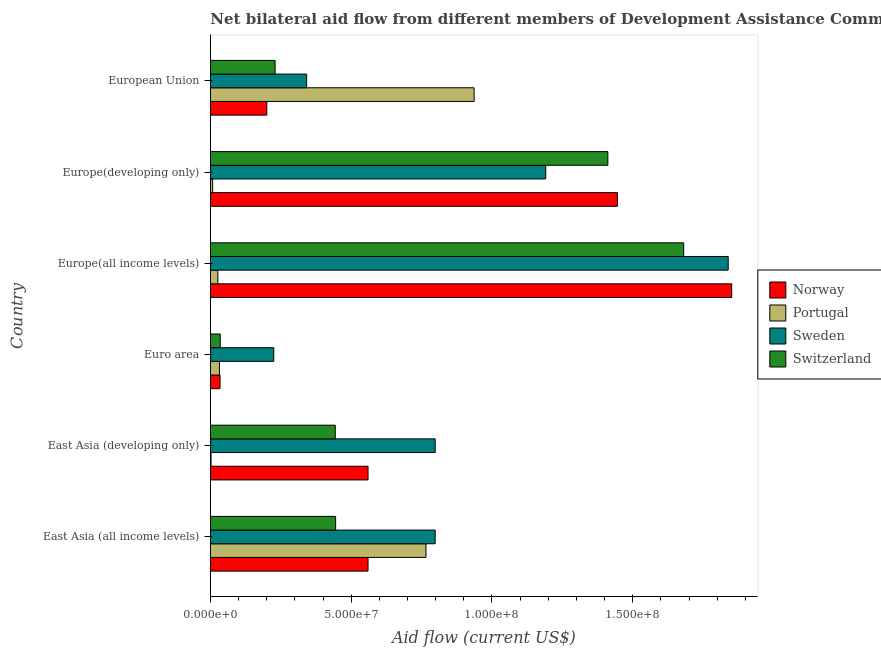Are the number of bars per tick equal to the number of legend labels?
Your answer should be compact. Yes. How many bars are there on the 6th tick from the top?
Your answer should be compact. 4. How many bars are there on the 2nd tick from the bottom?
Provide a short and direct response. 4. What is the label of the 3rd group of bars from the top?
Offer a very short reply. Europe(all income levels). In how many cases, is the number of bars for a given country not equal to the number of legend labels?
Make the answer very short. 0. What is the amount of aid given by norway in Euro area?
Provide a short and direct response. 3.40e+06. Across all countries, what is the maximum amount of aid given by portugal?
Offer a very short reply. 9.37e+07. Across all countries, what is the minimum amount of aid given by portugal?
Your response must be concise. 2.00e+05. In which country was the amount of aid given by sweden maximum?
Your answer should be very brief. Europe(all income levels). In which country was the amount of aid given by portugal minimum?
Provide a succinct answer. East Asia (developing only). What is the total amount of aid given by switzerland in the graph?
Your response must be concise. 4.24e+08. What is the difference between the amount of aid given by portugal in Europe(all income levels) and that in European Union?
Provide a short and direct response. -9.10e+07. What is the difference between the amount of aid given by sweden in East Asia (all income levels) and the amount of aid given by norway in East Asia (developing only)?
Give a very brief answer. 2.39e+07. What is the average amount of aid given by norway per country?
Provide a short and direct response. 7.75e+07. What is the difference between the amount of aid given by sweden and amount of aid given by norway in Europe(developing only)?
Offer a very short reply. -2.55e+07. What is the ratio of the amount of aid given by sweden in East Asia (developing only) to that in Europe(developing only)?
Keep it short and to the point. 0.67. Is the amount of aid given by switzerland in Europe(developing only) less than that in European Union?
Offer a terse response. No. Is the difference between the amount of aid given by portugal in East Asia (all income levels) and Euro area greater than the difference between the amount of aid given by norway in East Asia (all income levels) and Euro area?
Give a very brief answer. Yes. What is the difference between the highest and the second highest amount of aid given by switzerland?
Offer a very short reply. 2.69e+07. What is the difference between the highest and the lowest amount of aid given by norway?
Your answer should be compact. 1.82e+08. In how many countries, is the amount of aid given by portugal greater than the average amount of aid given by portugal taken over all countries?
Offer a terse response. 2. Is it the case that in every country, the sum of the amount of aid given by norway and amount of aid given by portugal is greater than the sum of amount of aid given by sweden and amount of aid given by switzerland?
Offer a terse response. No. What does the 4th bar from the bottom in European Union represents?
Your answer should be compact. Switzerland. Is it the case that in every country, the sum of the amount of aid given by norway and amount of aid given by portugal is greater than the amount of aid given by sweden?
Keep it short and to the point. No. Does the graph contain grids?
Offer a terse response. No. Where does the legend appear in the graph?
Make the answer very short. Center right. What is the title of the graph?
Give a very brief answer. Net bilateral aid flow from different members of Development Assistance Committee in the year 2002. Does "Structural Policies" appear as one of the legend labels in the graph?
Offer a terse response. No. What is the Aid flow (current US$) in Norway in East Asia (all income levels)?
Provide a short and direct response. 5.60e+07. What is the Aid flow (current US$) in Portugal in East Asia (all income levels)?
Provide a short and direct response. 7.66e+07. What is the Aid flow (current US$) of Sweden in East Asia (all income levels)?
Your answer should be compact. 7.98e+07. What is the Aid flow (current US$) in Switzerland in East Asia (all income levels)?
Keep it short and to the point. 4.45e+07. What is the Aid flow (current US$) in Norway in East Asia (developing only)?
Ensure brevity in your answer.  5.60e+07. What is the Aid flow (current US$) in Sweden in East Asia (developing only)?
Offer a terse response. 7.98e+07. What is the Aid flow (current US$) of Switzerland in East Asia (developing only)?
Make the answer very short. 4.43e+07. What is the Aid flow (current US$) of Norway in Euro area?
Give a very brief answer. 3.40e+06. What is the Aid flow (current US$) of Portugal in Euro area?
Your response must be concise. 3.18e+06. What is the Aid flow (current US$) in Sweden in Euro area?
Provide a short and direct response. 2.25e+07. What is the Aid flow (current US$) of Switzerland in Euro area?
Offer a terse response. 3.47e+06. What is the Aid flow (current US$) of Norway in Europe(all income levels)?
Offer a very short reply. 1.85e+08. What is the Aid flow (current US$) in Portugal in Europe(all income levels)?
Offer a terse response. 2.62e+06. What is the Aid flow (current US$) of Sweden in Europe(all income levels)?
Keep it short and to the point. 1.84e+08. What is the Aid flow (current US$) in Switzerland in Europe(all income levels)?
Offer a very short reply. 1.68e+08. What is the Aid flow (current US$) of Norway in Europe(developing only)?
Ensure brevity in your answer.  1.45e+08. What is the Aid flow (current US$) in Portugal in Europe(developing only)?
Keep it short and to the point. 7.70e+05. What is the Aid flow (current US$) of Sweden in Europe(developing only)?
Keep it short and to the point. 1.19e+08. What is the Aid flow (current US$) in Switzerland in Europe(developing only)?
Keep it short and to the point. 1.41e+08. What is the Aid flow (current US$) of Norway in European Union?
Give a very brief answer. 2.00e+07. What is the Aid flow (current US$) in Portugal in European Union?
Make the answer very short. 9.37e+07. What is the Aid flow (current US$) of Sweden in European Union?
Give a very brief answer. 3.42e+07. What is the Aid flow (current US$) of Switzerland in European Union?
Your response must be concise. 2.30e+07. Across all countries, what is the maximum Aid flow (current US$) of Norway?
Keep it short and to the point. 1.85e+08. Across all countries, what is the maximum Aid flow (current US$) of Portugal?
Keep it short and to the point. 9.37e+07. Across all countries, what is the maximum Aid flow (current US$) in Sweden?
Your answer should be compact. 1.84e+08. Across all countries, what is the maximum Aid flow (current US$) in Switzerland?
Give a very brief answer. 1.68e+08. Across all countries, what is the minimum Aid flow (current US$) of Norway?
Give a very brief answer. 3.40e+06. Across all countries, what is the minimum Aid flow (current US$) in Portugal?
Keep it short and to the point. 2.00e+05. Across all countries, what is the minimum Aid flow (current US$) of Sweden?
Keep it short and to the point. 2.25e+07. Across all countries, what is the minimum Aid flow (current US$) in Switzerland?
Provide a short and direct response. 3.47e+06. What is the total Aid flow (current US$) of Norway in the graph?
Ensure brevity in your answer.  4.65e+08. What is the total Aid flow (current US$) of Portugal in the graph?
Provide a short and direct response. 1.77e+08. What is the total Aid flow (current US$) of Sweden in the graph?
Provide a succinct answer. 5.19e+08. What is the total Aid flow (current US$) in Switzerland in the graph?
Provide a succinct answer. 4.24e+08. What is the difference between the Aid flow (current US$) of Norway in East Asia (all income levels) and that in East Asia (developing only)?
Offer a terse response. 0. What is the difference between the Aid flow (current US$) in Portugal in East Asia (all income levels) and that in East Asia (developing only)?
Give a very brief answer. 7.64e+07. What is the difference between the Aid flow (current US$) of Sweden in East Asia (all income levels) and that in East Asia (developing only)?
Provide a short and direct response. 0. What is the difference between the Aid flow (current US$) of Norway in East Asia (all income levels) and that in Euro area?
Your response must be concise. 5.26e+07. What is the difference between the Aid flow (current US$) of Portugal in East Asia (all income levels) and that in Euro area?
Offer a terse response. 7.34e+07. What is the difference between the Aid flow (current US$) of Sweden in East Asia (all income levels) and that in Euro area?
Your answer should be very brief. 5.73e+07. What is the difference between the Aid flow (current US$) in Switzerland in East Asia (all income levels) and that in Euro area?
Offer a terse response. 4.10e+07. What is the difference between the Aid flow (current US$) of Norway in East Asia (all income levels) and that in Europe(all income levels)?
Provide a succinct answer. -1.29e+08. What is the difference between the Aid flow (current US$) in Portugal in East Asia (all income levels) and that in Europe(all income levels)?
Provide a succinct answer. 7.39e+07. What is the difference between the Aid flow (current US$) in Sweden in East Asia (all income levels) and that in Europe(all income levels)?
Your answer should be very brief. -1.04e+08. What is the difference between the Aid flow (current US$) of Switzerland in East Asia (all income levels) and that in Europe(all income levels)?
Make the answer very short. -1.24e+08. What is the difference between the Aid flow (current US$) of Norway in East Asia (all income levels) and that in Europe(developing only)?
Offer a terse response. -8.86e+07. What is the difference between the Aid flow (current US$) in Portugal in East Asia (all income levels) and that in Europe(developing only)?
Your answer should be compact. 7.58e+07. What is the difference between the Aid flow (current US$) of Sweden in East Asia (all income levels) and that in Europe(developing only)?
Offer a terse response. -3.93e+07. What is the difference between the Aid flow (current US$) of Switzerland in East Asia (all income levels) and that in Europe(developing only)?
Your response must be concise. -9.67e+07. What is the difference between the Aid flow (current US$) of Norway in East Asia (all income levels) and that in European Union?
Keep it short and to the point. 3.60e+07. What is the difference between the Aid flow (current US$) in Portugal in East Asia (all income levels) and that in European Union?
Your response must be concise. -1.71e+07. What is the difference between the Aid flow (current US$) in Sweden in East Asia (all income levels) and that in European Union?
Keep it short and to the point. 4.57e+07. What is the difference between the Aid flow (current US$) of Switzerland in East Asia (all income levels) and that in European Union?
Make the answer very short. 2.15e+07. What is the difference between the Aid flow (current US$) in Norway in East Asia (developing only) and that in Euro area?
Give a very brief answer. 5.26e+07. What is the difference between the Aid flow (current US$) of Portugal in East Asia (developing only) and that in Euro area?
Give a very brief answer. -2.98e+06. What is the difference between the Aid flow (current US$) of Sweden in East Asia (developing only) and that in Euro area?
Your answer should be compact. 5.73e+07. What is the difference between the Aid flow (current US$) of Switzerland in East Asia (developing only) and that in Euro area?
Your response must be concise. 4.09e+07. What is the difference between the Aid flow (current US$) of Norway in East Asia (developing only) and that in Europe(all income levels)?
Provide a succinct answer. -1.29e+08. What is the difference between the Aid flow (current US$) in Portugal in East Asia (developing only) and that in Europe(all income levels)?
Give a very brief answer. -2.42e+06. What is the difference between the Aid flow (current US$) in Sweden in East Asia (developing only) and that in Europe(all income levels)?
Offer a terse response. -1.04e+08. What is the difference between the Aid flow (current US$) in Switzerland in East Asia (developing only) and that in Europe(all income levels)?
Provide a succinct answer. -1.24e+08. What is the difference between the Aid flow (current US$) in Norway in East Asia (developing only) and that in Europe(developing only)?
Keep it short and to the point. -8.86e+07. What is the difference between the Aid flow (current US$) of Portugal in East Asia (developing only) and that in Europe(developing only)?
Your response must be concise. -5.70e+05. What is the difference between the Aid flow (current US$) in Sweden in East Asia (developing only) and that in Europe(developing only)?
Offer a terse response. -3.93e+07. What is the difference between the Aid flow (current US$) of Switzerland in East Asia (developing only) and that in Europe(developing only)?
Offer a terse response. -9.68e+07. What is the difference between the Aid flow (current US$) of Norway in East Asia (developing only) and that in European Union?
Offer a very short reply. 3.60e+07. What is the difference between the Aid flow (current US$) in Portugal in East Asia (developing only) and that in European Union?
Provide a short and direct response. -9.35e+07. What is the difference between the Aid flow (current US$) in Sweden in East Asia (developing only) and that in European Union?
Provide a short and direct response. 4.57e+07. What is the difference between the Aid flow (current US$) of Switzerland in East Asia (developing only) and that in European Union?
Your response must be concise. 2.14e+07. What is the difference between the Aid flow (current US$) in Norway in Euro area and that in Europe(all income levels)?
Offer a terse response. -1.82e+08. What is the difference between the Aid flow (current US$) in Portugal in Euro area and that in Europe(all income levels)?
Ensure brevity in your answer.  5.60e+05. What is the difference between the Aid flow (current US$) in Sweden in Euro area and that in Europe(all income levels)?
Your answer should be very brief. -1.61e+08. What is the difference between the Aid flow (current US$) in Switzerland in Euro area and that in Europe(all income levels)?
Provide a short and direct response. -1.65e+08. What is the difference between the Aid flow (current US$) in Norway in Euro area and that in Europe(developing only)?
Your response must be concise. -1.41e+08. What is the difference between the Aid flow (current US$) in Portugal in Euro area and that in Europe(developing only)?
Give a very brief answer. 2.41e+06. What is the difference between the Aid flow (current US$) in Sweden in Euro area and that in Europe(developing only)?
Keep it short and to the point. -9.66e+07. What is the difference between the Aid flow (current US$) of Switzerland in Euro area and that in Europe(developing only)?
Your answer should be compact. -1.38e+08. What is the difference between the Aid flow (current US$) of Norway in Euro area and that in European Union?
Your response must be concise. -1.66e+07. What is the difference between the Aid flow (current US$) in Portugal in Euro area and that in European Union?
Provide a short and direct response. -9.05e+07. What is the difference between the Aid flow (current US$) in Sweden in Euro area and that in European Union?
Make the answer very short. -1.17e+07. What is the difference between the Aid flow (current US$) of Switzerland in Euro area and that in European Union?
Ensure brevity in your answer.  -1.95e+07. What is the difference between the Aid flow (current US$) in Norway in Europe(all income levels) and that in Europe(developing only)?
Ensure brevity in your answer.  4.06e+07. What is the difference between the Aid flow (current US$) in Portugal in Europe(all income levels) and that in Europe(developing only)?
Your answer should be very brief. 1.85e+06. What is the difference between the Aid flow (current US$) of Sweden in Europe(all income levels) and that in Europe(developing only)?
Provide a short and direct response. 6.48e+07. What is the difference between the Aid flow (current US$) in Switzerland in Europe(all income levels) and that in Europe(developing only)?
Provide a short and direct response. 2.69e+07. What is the difference between the Aid flow (current US$) in Norway in Europe(all income levels) and that in European Union?
Provide a short and direct response. 1.65e+08. What is the difference between the Aid flow (current US$) in Portugal in Europe(all income levels) and that in European Union?
Keep it short and to the point. -9.10e+07. What is the difference between the Aid flow (current US$) of Sweden in Europe(all income levels) and that in European Union?
Provide a succinct answer. 1.50e+08. What is the difference between the Aid flow (current US$) of Switzerland in Europe(all income levels) and that in European Union?
Your answer should be compact. 1.45e+08. What is the difference between the Aid flow (current US$) of Norway in Europe(developing only) and that in European Union?
Your answer should be compact. 1.25e+08. What is the difference between the Aid flow (current US$) of Portugal in Europe(developing only) and that in European Union?
Your answer should be compact. -9.29e+07. What is the difference between the Aid flow (current US$) in Sweden in Europe(developing only) and that in European Union?
Provide a succinct answer. 8.49e+07. What is the difference between the Aid flow (current US$) in Switzerland in Europe(developing only) and that in European Union?
Give a very brief answer. 1.18e+08. What is the difference between the Aid flow (current US$) of Norway in East Asia (all income levels) and the Aid flow (current US$) of Portugal in East Asia (developing only)?
Your answer should be compact. 5.58e+07. What is the difference between the Aid flow (current US$) in Norway in East Asia (all income levels) and the Aid flow (current US$) in Sweden in East Asia (developing only)?
Your answer should be compact. -2.39e+07. What is the difference between the Aid flow (current US$) of Norway in East Asia (all income levels) and the Aid flow (current US$) of Switzerland in East Asia (developing only)?
Give a very brief answer. 1.16e+07. What is the difference between the Aid flow (current US$) of Portugal in East Asia (all income levels) and the Aid flow (current US$) of Sweden in East Asia (developing only)?
Your answer should be very brief. -3.27e+06. What is the difference between the Aid flow (current US$) of Portugal in East Asia (all income levels) and the Aid flow (current US$) of Switzerland in East Asia (developing only)?
Offer a terse response. 3.22e+07. What is the difference between the Aid flow (current US$) in Sweden in East Asia (all income levels) and the Aid flow (current US$) in Switzerland in East Asia (developing only)?
Keep it short and to the point. 3.55e+07. What is the difference between the Aid flow (current US$) in Norway in East Asia (all income levels) and the Aid flow (current US$) in Portugal in Euro area?
Give a very brief answer. 5.28e+07. What is the difference between the Aid flow (current US$) of Norway in East Asia (all income levels) and the Aid flow (current US$) of Sweden in Euro area?
Your answer should be very brief. 3.35e+07. What is the difference between the Aid flow (current US$) of Norway in East Asia (all income levels) and the Aid flow (current US$) of Switzerland in Euro area?
Offer a very short reply. 5.25e+07. What is the difference between the Aid flow (current US$) in Portugal in East Asia (all income levels) and the Aid flow (current US$) in Sweden in Euro area?
Your response must be concise. 5.41e+07. What is the difference between the Aid flow (current US$) in Portugal in East Asia (all income levels) and the Aid flow (current US$) in Switzerland in Euro area?
Your answer should be very brief. 7.31e+07. What is the difference between the Aid flow (current US$) of Sweden in East Asia (all income levels) and the Aid flow (current US$) of Switzerland in Euro area?
Make the answer very short. 7.64e+07. What is the difference between the Aid flow (current US$) of Norway in East Asia (all income levels) and the Aid flow (current US$) of Portugal in Europe(all income levels)?
Keep it short and to the point. 5.34e+07. What is the difference between the Aid flow (current US$) in Norway in East Asia (all income levels) and the Aid flow (current US$) in Sweden in Europe(all income levels)?
Your response must be concise. -1.28e+08. What is the difference between the Aid flow (current US$) in Norway in East Asia (all income levels) and the Aid flow (current US$) in Switzerland in Europe(all income levels)?
Your response must be concise. -1.12e+08. What is the difference between the Aid flow (current US$) in Portugal in East Asia (all income levels) and the Aid flow (current US$) in Sweden in Europe(all income levels)?
Ensure brevity in your answer.  -1.07e+08. What is the difference between the Aid flow (current US$) in Portugal in East Asia (all income levels) and the Aid flow (current US$) in Switzerland in Europe(all income levels)?
Make the answer very short. -9.16e+07. What is the difference between the Aid flow (current US$) in Sweden in East Asia (all income levels) and the Aid flow (current US$) in Switzerland in Europe(all income levels)?
Provide a succinct answer. -8.83e+07. What is the difference between the Aid flow (current US$) in Norway in East Asia (all income levels) and the Aid flow (current US$) in Portugal in Europe(developing only)?
Provide a short and direct response. 5.52e+07. What is the difference between the Aid flow (current US$) in Norway in East Asia (all income levels) and the Aid flow (current US$) in Sweden in Europe(developing only)?
Offer a very short reply. -6.31e+07. What is the difference between the Aid flow (current US$) in Norway in East Asia (all income levels) and the Aid flow (current US$) in Switzerland in Europe(developing only)?
Give a very brief answer. -8.52e+07. What is the difference between the Aid flow (current US$) in Portugal in East Asia (all income levels) and the Aid flow (current US$) in Sweden in Europe(developing only)?
Provide a short and direct response. -4.25e+07. What is the difference between the Aid flow (current US$) in Portugal in East Asia (all income levels) and the Aid flow (current US$) in Switzerland in Europe(developing only)?
Ensure brevity in your answer.  -6.46e+07. What is the difference between the Aid flow (current US$) in Sweden in East Asia (all income levels) and the Aid flow (current US$) in Switzerland in Europe(developing only)?
Offer a terse response. -6.13e+07. What is the difference between the Aid flow (current US$) in Norway in East Asia (all income levels) and the Aid flow (current US$) in Portugal in European Union?
Your response must be concise. -3.77e+07. What is the difference between the Aid flow (current US$) in Norway in East Asia (all income levels) and the Aid flow (current US$) in Sweden in European Union?
Provide a succinct answer. 2.18e+07. What is the difference between the Aid flow (current US$) of Norway in East Asia (all income levels) and the Aid flow (current US$) of Switzerland in European Union?
Make the answer very short. 3.30e+07. What is the difference between the Aid flow (current US$) in Portugal in East Asia (all income levels) and the Aid flow (current US$) in Sweden in European Union?
Provide a short and direct response. 4.24e+07. What is the difference between the Aid flow (current US$) of Portugal in East Asia (all income levels) and the Aid flow (current US$) of Switzerland in European Union?
Ensure brevity in your answer.  5.36e+07. What is the difference between the Aid flow (current US$) in Sweden in East Asia (all income levels) and the Aid flow (current US$) in Switzerland in European Union?
Provide a succinct answer. 5.69e+07. What is the difference between the Aid flow (current US$) in Norway in East Asia (developing only) and the Aid flow (current US$) in Portugal in Euro area?
Provide a short and direct response. 5.28e+07. What is the difference between the Aid flow (current US$) in Norway in East Asia (developing only) and the Aid flow (current US$) in Sweden in Euro area?
Provide a succinct answer. 3.35e+07. What is the difference between the Aid flow (current US$) of Norway in East Asia (developing only) and the Aid flow (current US$) of Switzerland in Euro area?
Your response must be concise. 5.25e+07. What is the difference between the Aid flow (current US$) of Portugal in East Asia (developing only) and the Aid flow (current US$) of Sweden in Euro area?
Provide a short and direct response. -2.23e+07. What is the difference between the Aid flow (current US$) of Portugal in East Asia (developing only) and the Aid flow (current US$) of Switzerland in Euro area?
Offer a very short reply. -3.27e+06. What is the difference between the Aid flow (current US$) of Sweden in East Asia (developing only) and the Aid flow (current US$) of Switzerland in Euro area?
Your answer should be very brief. 7.64e+07. What is the difference between the Aid flow (current US$) in Norway in East Asia (developing only) and the Aid flow (current US$) in Portugal in Europe(all income levels)?
Give a very brief answer. 5.34e+07. What is the difference between the Aid flow (current US$) of Norway in East Asia (developing only) and the Aid flow (current US$) of Sweden in Europe(all income levels)?
Provide a succinct answer. -1.28e+08. What is the difference between the Aid flow (current US$) in Norway in East Asia (developing only) and the Aid flow (current US$) in Switzerland in Europe(all income levels)?
Provide a short and direct response. -1.12e+08. What is the difference between the Aid flow (current US$) of Portugal in East Asia (developing only) and the Aid flow (current US$) of Sweden in Europe(all income levels)?
Your answer should be compact. -1.84e+08. What is the difference between the Aid flow (current US$) of Portugal in East Asia (developing only) and the Aid flow (current US$) of Switzerland in Europe(all income levels)?
Give a very brief answer. -1.68e+08. What is the difference between the Aid flow (current US$) in Sweden in East Asia (developing only) and the Aid flow (current US$) in Switzerland in Europe(all income levels)?
Keep it short and to the point. -8.83e+07. What is the difference between the Aid flow (current US$) of Norway in East Asia (developing only) and the Aid flow (current US$) of Portugal in Europe(developing only)?
Your answer should be compact. 5.52e+07. What is the difference between the Aid flow (current US$) of Norway in East Asia (developing only) and the Aid flow (current US$) of Sweden in Europe(developing only)?
Make the answer very short. -6.31e+07. What is the difference between the Aid flow (current US$) in Norway in East Asia (developing only) and the Aid flow (current US$) in Switzerland in Europe(developing only)?
Your response must be concise. -8.52e+07. What is the difference between the Aid flow (current US$) of Portugal in East Asia (developing only) and the Aid flow (current US$) of Sweden in Europe(developing only)?
Offer a terse response. -1.19e+08. What is the difference between the Aid flow (current US$) in Portugal in East Asia (developing only) and the Aid flow (current US$) in Switzerland in Europe(developing only)?
Your answer should be very brief. -1.41e+08. What is the difference between the Aid flow (current US$) of Sweden in East Asia (developing only) and the Aid flow (current US$) of Switzerland in Europe(developing only)?
Provide a succinct answer. -6.13e+07. What is the difference between the Aid flow (current US$) in Norway in East Asia (developing only) and the Aid flow (current US$) in Portugal in European Union?
Provide a short and direct response. -3.77e+07. What is the difference between the Aid flow (current US$) of Norway in East Asia (developing only) and the Aid flow (current US$) of Sweden in European Union?
Provide a short and direct response. 2.18e+07. What is the difference between the Aid flow (current US$) of Norway in East Asia (developing only) and the Aid flow (current US$) of Switzerland in European Union?
Your response must be concise. 3.30e+07. What is the difference between the Aid flow (current US$) in Portugal in East Asia (developing only) and the Aid flow (current US$) in Sweden in European Union?
Provide a short and direct response. -3.40e+07. What is the difference between the Aid flow (current US$) of Portugal in East Asia (developing only) and the Aid flow (current US$) of Switzerland in European Union?
Keep it short and to the point. -2.28e+07. What is the difference between the Aid flow (current US$) of Sweden in East Asia (developing only) and the Aid flow (current US$) of Switzerland in European Union?
Ensure brevity in your answer.  5.69e+07. What is the difference between the Aid flow (current US$) of Norway in Euro area and the Aid flow (current US$) of Portugal in Europe(all income levels)?
Provide a succinct answer. 7.80e+05. What is the difference between the Aid flow (current US$) in Norway in Euro area and the Aid flow (current US$) in Sweden in Europe(all income levels)?
Give a very brief answer. -1.81e+08. What is the difference between the Aid flow (current US$) of Norway in Euro area and the Aid flow (current US$) of Switzerland in Europe(all income levels)?
Your answer should be compact. -1.65e+08. What is the difference between the Aid flow (current US$) of Portugal in Euro area and the Aid flow (current US$) of Sweden in Europe(all income levels)?
Keep it short and to the point. -1.81e+08. What is the difference between the Aid flow (current US$) in Portugal in Euro area and the Aid flow (current US$) in Switzerland in Europe(all income levels)?
Offer a very short reply. -1.65e+08. What is the difference between the Aid flow (current US$) of Sweden in Euro area and the Aid flow (current US$) of Switzerland in Europe(all income levels)?
Provide a succinct answer. -1.46e+08. What is the difference between the Aid flow (current US$) in Norway in Euro area and the Aid flow (current US$) in Portugal in Europe(developing only)?
Offer a terse response. 2.63e+06. What is the difference between the Aid flow (current US$) of Norway in Euro area and the Aid flow (current US$) of Sweden in Europe(developing only)?
Make the answer very short. -1.16e+08. What is the difference between the Aid flow (current US$) in Norway in Euro area and the Aid flow (current US$) in Switzerland in Europe(developing only)?
Offer a very short reply. -1.38e+08. What is the difference between the Aid flow (current US$) of Portugal in Euro area and the Aid flow (current US$) of Sweden in Europe(developing only)?
Offer a terse response. -1.16e+08. What is the difference between the Aid flow (current US$) of Portugal in Euro area and the Aid flow (current US$) of Switzerland in Europe(developing only)?
Your answer should be compact. -1.38e+08. What is the difference between the Aid flow (current US$) of Sweden in Euro area and the Aid flow (current US$) of Switzerland in Europe(developing only)?
Ensure brevity in your answer.  -1.19e+08. What is the difference between the Aid flow (current US$) of Norway in Euro area and the Aid flow (current US$) of Portugal in European Union?
Your answer should be compact. -9.03e+07. What is the difference between the Aid flow (current US$) of Norway in Euro area and the Aid flow (current US$) of Sweden in European Union?
Give a very brief answer. -3.08e+07. What is the difference between the Aid flow (current US$) in Norway in Euro area and the Aid flow (current US$) in Switzerland in European Union?
Give a very brief answer. -1.96e+07. What is the difference between the Aid flow (current US$) of Portugal in Euro area and the Aid flow (current US$) of Sweden in European Union?
Your answer should be compact. -3.10e+07. What is the difference between the Aid flow (current US$) in Portugal in Euro area and the Aid flow (current US$) in Switzerland in European Union?
Give a very brief answer. -1.98e+07. What is the difference between the Aid flow (current US$) in Sweden in Euro area and the Aid flow (current US$) in Switzerland in European Union?
Offer a terse response. -4.70e+05. What is the difference between the Aid flow (current US$) in Norway in Europe(all income levels) and the Aid flow (current US$) in Portugal in Europe(developing only)?
Provide a short and direct response. 1.84e+08. What is the difference between the Aid flow (current US$) in Norway in Europe(all income levels) and the Aid flow (current US$) in Sweden in Europe(developing only)?
Keep it short and to the point. 6.61e+07. What is the difference between the Aid flow (current US$) of Norway in Europe(all income levels) and the Aid flow (current US$) of Switzerland in Europe(developing only)?
Give a very brief answer. 4.40e+07. What is the difference between the Aid flow (current US$) in Portugal in Europe(all income levels) and the Aid flow (current US$) in Sweden in Europe(developing only)?
Provide a short and direct response. -1.16e+08. What is the difference between the Aid flow (current US$) in Portugal in Europe(all income levels) and the Aid flow (current US$) in Switzerland in Europe(developing only)?
Provide a succinct answer. -1.39e+08. What is the difference between the Aid flow (current US$) of Sweden in Europe(all income levels) and the Aid flow (current US$) of Switzerland in Europe(developing only)?
Provide a succinct answer. 4.28e+07. What is the difference between the Aid flow (current US$) in Norway in Europe(all income levels) and the Aid flow (current US$) in Portugal in European Union?
Make the answer very short. 9.15e+07. What is the difference between the Aid flow (current US$) of Norway in Europe(all income levels) and the Aid flow (current US$) of Sweden in European Union?
Your response must be concise. 1.51e+08. What is the difference between the Aid flow (current US$) in Norway in Europe(all income levels) and the Aid flow (current US$) in Switzerland in European Union?
Make the answer very short. 1.62e+08. What is the difference between the Aid flow (current US$) of Portugal in Europe(all income levels) and the Aid flow (current US$) of Sweden in European Union?
Your answer should be compact. -3.16e+07. What is the difference between the Aid flow (current US$) in Portugal in Europe(all income levels) and the Aid flow (current US$) in Switzerland in European Union?
Your response must be concise. -2.03e+07. What is the difference between the Aid flow (current US$) in Sweden in Europe(all income levels) and the Aid flow (current US$) in Switzerland in European Union?
Make the answer very short. 1.61e+08. What is the difference between the Aid flow (current US$) in Norway in Europe(developing only) and the Aid flow (current US$) in Portugal in European Union?
Provide a succinct answer. 5.09e+07. What is the difference between the Aid flow (current US$) in Norway in Europe(developing only) and the Aid flow (current US$) in Sweden in European Union?
Provide a succinct answer. 1.10e+08. What is the difference between the Aid flow (current US$) in Norway in Europe(developing only) and the Aid flow (current US$) in Switzerland in European Union?
Provide a succinct answer. 1.22e+08. What is the difference between the Aid flow (current US$) of Portugal in Europe(developing only) and the Aid flow (current US$) of Sweden in European Union?
Ensure brevity in your answer.  -3.34e+07. What is the difference between the Aid flow (current US$) in Portugal in Europe(developing only) and the Aid flow (current US$) in Switzerland in European Union?
Give a very brief answer. -2.22e+07. What is the difference between the Aid flow (current US$) in Sweden in Europe(developing only) and the Aid flow (current US$) in Switzerland in European Union?
Your answer should be very brief. 9.61e+07. What is the average Aid flow (current US$) of Norway per country?
Ensure brevity in your answer.  7.75e+07. What is the average Aid flow (current US$) in Portugal per country?
Make the answer very short. 2.95e+07. What is the average Aid flow (current US$) of Sweden per country?
Make the answer very short. 8.66e+07. What is the average Aid flow (current US$) of Switzerland per country?
Provide a short and direct response. 7.08e+07. What is the difference between the Aid flow (current US$) in Norway and Aid flow (current US$) in Portugal in East Asia (all income levels)?
Your response must be concise. -2.06e+07. What is the difference between the Aid flow (current US$) of Norway and Aid flow (current US$) of Sweden in East Asia (all income levels)?
Offer a very short reply. -2.39e+07. What is the difference between the Aid flow (current US$) in Norway and Aid flow (current US$) in Switzerland in East Asia (all income levels)?
Make the answer very short. 1.15e+07. What is the difference between the Aid flow (current US$) in Portugal and Aid flow (current US$) in Sweden in East Asia (all income levels)?
Your answer should be very brief. -3.27e+06. What is the difference between the Aid flow (current US$) of Portugal and Aid flow (current US$) of Switzerland in East Asia (all income levels)?
Offer a terse response. 3.21e+07. What is the difference between the Aid flow (current US$) of Sweden and Aid flow (current US$) of Switzerland in East Asia (all income levels)?
Give a very brief answer. 3.54e+07. What is the difference between the Aid flow (current US$) of Norway and Aid flow (current US$) of Portugal in East Asia (developing only)?
Give a very brief answer. 5.58e+07. What is the difference between the Aid flow (current US$) of Norway and Aid flow (current US$) of Sweden in East Asia (developing only)?
Your response must be concise. -2.39e+07. What is the difference between the Aid flow (current US$) of Norway and Aid flow (current US$) of Switzerland in East Asia (developing only)?
Make the answer very short. 1.16e+07. What is the difference between the Aid flow (current US$) in Portugal and Aid flow (current US$) in Sweden in East Asia (developing only)?
Make the answer very short. -7.96e+07. What is the difference between the Aid flow (current US$) of Portugal and Aid flow (current US$) of Switzerland in East Asia (developing only)?
Provide a succinct answer. -4.41e+07. What is the difference between the Aid flow (current US$) in Sweden and Aid flow (current US$) in Switzerland in East Asia (developing only)?
Keep it short and to the point. 3.55e+07. What is the difference between the Aid flow (current US$) of Norway and Aid flow (current US$) of Sweden in Euro area?
Your answer should be very brief. -1.91e+07. What is the difference between the Aid flow (current US$) of Portugal and Aid flow (current US$) of Sweden in Euro area?
Your response must be concise. -1.93e+07. What is the difference between the Aid flow (current US$) in Sweden and Aid flow (current US$) in Switzerland in Euro area?
Your answer should be very brief. 1.90e+07. What is the difference between the Aid flow (current US$) of Norway and Aid flow (current US$) of Portugal in Europe(all income levels)?
Ensure brevity in your answer.  1.83e+08. What is the difference between the Aid flow (current US$) in Norway and Aid flow (current US$) in Sweden in Europe(all income levels)?
Make the answer very short. 1.25e+06. What is the difference between the Aid flow (current US$) in Norway and Aid flow (current US$) in Switzerland in Europe(all income levels)?
Offer a terse response. 1.71e+07. What is the difference between the Aid flow (current US$) of Portugal and Aid flow (current US$) of Sweden in Europe(all income levels)?
Your answer should be compact. -1.81e+08. What is the difference between the Aid flow (current US$) in Portugal and Aid flow (current US$) in Switzerland in Europe(all income levels)?
Provide a short and direct response. -1.65e+08. What is the difference between the Aid flow (current US$) of Sweden and Aid flow (current US$) of Switzerland in Europe(all income levels)?
Provide a succinct answer. 1.58e+07. What is the difference between the Aid flow (current US$) of Norway and Aid flow (current US$) of Portugal in Europe(developing only)?
Provide a succinct answer. 1.44e+08. What is the difference between the Aid flow (current US$) in Norway and Aid flow (current US$) in Sweden in Europe(developing only)?
Your answer should be very brief. 2.55e+07. What is the difference between the Aid flow (current US$) of Norway and Aid flow (current US$) of Switzerland in Europe(developing only)?
Provide a short and direct response. 3.39e+06. What is the difference between the Aid flow (current US$) in Portugal and Aid flow (current US$) in Sweden in Europe(developing only)?
Your answer should be compact. -1.18e+08. What is the difference between the Aid flow (current US$) in Portugal and Aid flow (current US$) in Switzerland in Europe(developing only)?
Ensure brevity in your answer.  -1.40e+08. What is the difference between the Aid flow (current US$) of Sweden and Aid flow (current US$) of Switzerland in Europe(developing only)?
Provide a short and direct response. -2.21e+07. What is the difference between the Aid flow (current US$) of Norway and Aid flow (current US$) of Portugal in European Union?
Ensure brevity in your answer.  -7.36e+07. What is the difference between the Aid flow (current US$) of Norway and Aid flow (current US$) of Sweden in European Union?
Your answer should be compact. -1.42e+07. What is the difference between the Aid flow (current US$) of Norway and Aid flow (current US$) of Switzerland in European Union?
Your response must be concise. -2.94e+06. What is the difference between the Aid flow (current US$) of Portugal and Aid flow (current US$) of Sweden in European Union?
Make the answer very short. 5.95e+07. What is the difference between the Aid flow (current US$) of Portugal and Aid flow (current US$) of Switzerland in European Union?
Provide a short and direct response. 7.07e+07. What is the difference between the Aid flow (current US$) in Sweden and Aid flow (current US$) in Switzerland in European Union?
Your response must be concise. 1.12e+07. What is the ratio of the Aid flow (current US$) of Portugal in East Asia (all income levels) to that in East Asia (developing only)?
Provide a short and direct response. 382.8. What is the ratio of the Aid flow (current US$) in Norway in East Asia (all income levels) to that in Euro area?
Offer a very short reply. 16.46. What is the ratio of the Aid flow (current US$) of Portugal in East Asia (all income levels) to that in Euro area?
Provide a short and direct response. 24.08. What is the ratio of the Aid flow (current US$) in Sweden in East Asia (all income levels) to that in Euro area?
Your answer should be compact. 3.55. What is the ratio of the Aid flow (current US$) in Switzerland in East Asia (all income levels) to that in Euro area?
Make the answer very short. 12.81. What is the ratio of the Aid flow (current US$) in Norway in East Asia (all income levels) to that in Europe(all income levels)?
Provide a succinct answer. 0.3. What is the ratio of the Aid flow (current US$) in Portugal in East Asia (all income levels) to that in Europe(all income levels)?
Offer a terse response. 29.22. What is the ratio of the Aid flow (current US$) in Sweden in East Asia (all income levels) to that in Europe(all income levels)?
Offer a very short reply. 0.43. What is the ratio of the Aid flow (current US$) in Switzerland in East Asia (all income levels) to that in Europe(all income levels)?
Keep it short and to the point. 0.26. What is the ratio of the Aid flow (current US$) of Norway in East Asia (all income levels) to that in Europe(developing only)?
Give a very brief answer. 0.39. What is the ratio of the Aid flow (current US$) of Portugal in East Asia (all income levels) to that in Europe(developing only)?
Your answer should be compact. 99.43. What is the ratio of the Aid flow (current US$) in Sweden in East Asia (all income levels) to that in Europe(developing only)?
Offer a very short reply. 0.67. What is the ratio of the Aid flow (current US$) of Switzerland in East Asia (all income levels) to that in Europe(developing only)?
Your answer should be compact. 0.31. What is the ratio of the Aid flow (current US$) in Norway in East Asia (all income levels) to that in European Union?
Offer a very short reply. 2.8. What is the ratio of the Aid flow (current US$) of Portugal in East Asia (all income levels) to that in European Union?
Make the answer very short. 0.82. What is the ratio of the Aid flow (current US$) of Sweden in East Asia (all income levels) to that in European Union?
Provide a succinct answer. 2.34. What is the ratio of the Aid flow (current US$) in Switzerland in East Asia (all income levels) to that in European Union?
Ensure brevity in your answer.  1.94. What is the ratio of the Aid flow (current US$) in Norway in East Asia (developing only) to that in Euro area?
Keep it short and to the point. 16.46. What is the ratio of the Aid flow (current US$) of Portugal in East Asia (developing only) to that in Euro area?
Make the answer very short. 0.06. What is the ratio of the Aid flow (current US$) in Sweden in East Asia (developing only) to that in Euro area?
Your answer should be very brief. 3.55. What is the ratio of the Aid flow (current US$) in Switzerland in East Asia (developing only) to that in Euro area?
Offer a terse response. 12.78. What is the ratio of the Aid flow (current US$) in Norway in East Asia (developing only) to that in Europe(all income levels)?
Your response must be concise. 0.3. What is the ratio of the Aid flow (current US$) of Portugal in East Asia (developing only) to that in Europe(all income levels)?
Provide a short and direct response. 0.08. What is the ratio of the Aid flow (current US$) of Sweden in East Asia (developing only) to that in Europe(all income levels)?
Your answer should be compact. 0.43. What is the ratio of the Aid flow (current US$) in Switzerland in East Asia (developing only) to that in Europe(all income levels)?
Your answer should be very brief. 0.26. What is the ratio of the Aid flow (current US$) of Norway in East Asia (developing only) to that in Europe(developing only)?
Offer a very short reply. 0.39. What is the ratio of the Aid flow (current US$) in Portugal in East Asia (developing only) to that in Europe(developing only)?
Ensure brevity in your answer.  0.26. What is the ratio of the Aid flow (current US$) of Sweden in East Asia (developing only) to that in Europe(developing only)?
Your answer should be very brief. 0.67. What is the ratio of the Aid flow (current US$) in Switzerland in East Asia (developing only) to that in Europe(developing only)?
Make the answer very short. 0.31. What is the ratio of the Aid flow (current US$) of Norway in East Asia (developing only) to that in European Union?
Ensure brevity in your answer.  2.8. What is the ratio of the Aid flow (current US$) in Portugal in East Asia (developing only) to that in European Union?
Your response must be concise. 0. What is the ratio of the Aid flow (current US$) of Sweden in East Asia (developing only) to that in European Union?
Keep it short and to the point. 2.34. What is the ratio of the Aid flow (current US$) in Switzerland in East Asia (developing only) to that in European Union?
Provide a short and direct response. 1.93. What is the ratio of the Aid flow (current US$) in Norway in Euro area to that in Europe(all income levels)?
Your answer should be very brief. 0.02. What is the ratio of the Aid flow (current US$) of Portugal in Euro area to that in Europe(all income levels)?
Your response must be concise. 1.21. What is the ratio of the Aid flow (current US$) of Sweden in Euro area to that in Europe(all income levels)?
Make the answer very short. 0.12. What is the ratio of the Aid flow (current US$) in Switzerland in Euro area to that in Europe(all income levels)?
Offer a very short reply. 0.02. What is the ratio of the Aid flow (current US$) of Norway in Euro area to that in Europe(developing only)?
Offer a very short reply. 0.02. What is the ratio of the Aid flow (current US$) in Portugal in Euro area to that in Europe(developing only)?
Offer a terse response. 4.13. What is the ratio of the Aid flow (current US$) in Sweden in Euro area to that in Europe(developing only)?
Ensure brevity in your answer.  0.19. What is the ratio of the Aid flow (current US$) of Switzerland in Euro area to that in Europe(developing only)?
Give a very brief answer. 0.02. What is the ratio of the Aid flow (current US$) of Norway in Euro area to that in European Union?
Give a very brief answer. 0.17. What is the ratio of the Aid flow (current US$) in Portugal in Euro area to that in European Union?
Keep it short and to the point. 0.03. What is the ratio of the Aid flow (current US$) in Sweden in Euro area to that in European Union?
Give a very brief answer. 0.66. What is the ratio of the Aid flow (current US$) in Switzerland in Euro area to that in European Union?
Make the answer very short. 0.15. What is the ratio of the Aid flow (current US$) of Norway in Europe(all income levels) to that in Europe(developing only)?
Give a very brief answer. 1.28. What is the ratio of the Aid flow (current US$) of Portugal in Europe(all income levels) to that in Europe(developing only)?
Your answer should be very brief. 3.4. What is the ratio of the Aid flow (current US$) of Sweden in Europe(all income levels) to that in Europe(developing only)?
Your response must be concise. 1.54. What is the ratio of the Aid flow (current US$) of Switzerland in Europe(all income levels) to that in Europe(developing only)?
Your response must be concise. 1.19. What is the ratio of the Aid flow (current US$) in Norway in Europe(all income levels) to that in European Union?
Give a very brief answer. 9.25. What is the ratio of the Aid flow (current US$) in Portugal in Europe(all income levels) to that in European Union?
Keep it short and to the point. 0.03. What is the ratio of the Aid flow (current US$) in Sweden in Europe(all income levels) to that in European Union?
Make the answer very short. 5.38. What is the ratio of the Aid flow (current US$) in Switzerland in Europe(all income levels) to that in European Union?
Ensure brevity in your answer.  7.32. What is the ratio of the Aid flow (current US$) in Norway in Europe(developing only) to that in European Union?
Make the answer very short. 7.22. What is the ratio of the Aid flow (current US$) in Portugal in Europe(developing only) to that in European Union?
Your answer should be very brief. 0.01. What is the ratio of the Aid flow (current US$) in Sweden in Europe(developing only) to that in European Union?
Provide a short and direct response. 3.49. What is the ratio of the Aid flow (current US$) of Switzerland in Europe(developing only) to that in European Union?
Offer a very short reply. 6.15. What is the difference between the highest and the second highest Aid flow (current US$) of Norway?
Your response must be concise. 4.06e+07. What is the difference between the highest and the second highest Aid flow (current US$) of Portugal?
Your response must be concise. 1.71e+07. What is the difference between the highest and the second highest Aid flow (current US$) of Sweden?
Your answer should be very brief. 6.48e+07. What is the difference between the highest and the second highest Aid flow (current US$) of Switzerland?
Your answer should be compact. 2.69e+07. What is the difference between the highest and the lowest Aid flow (current US$) of Norway?
Your answer should be compact. 1.82e+08. What is the difference between the highest and the lowest Aid flow (current US$) in Portugal?
Ensure brevity in your answer.  9.35e+07. What is the difference between the highest and the lowest Aid flow (current US$) in Sweden?
Your response must be concise. 1.61e+08. What is the difference between the highest and the lowest Aid flow (current US$) in Switzerland?
Offer a very short reply. 1.65e+08. 